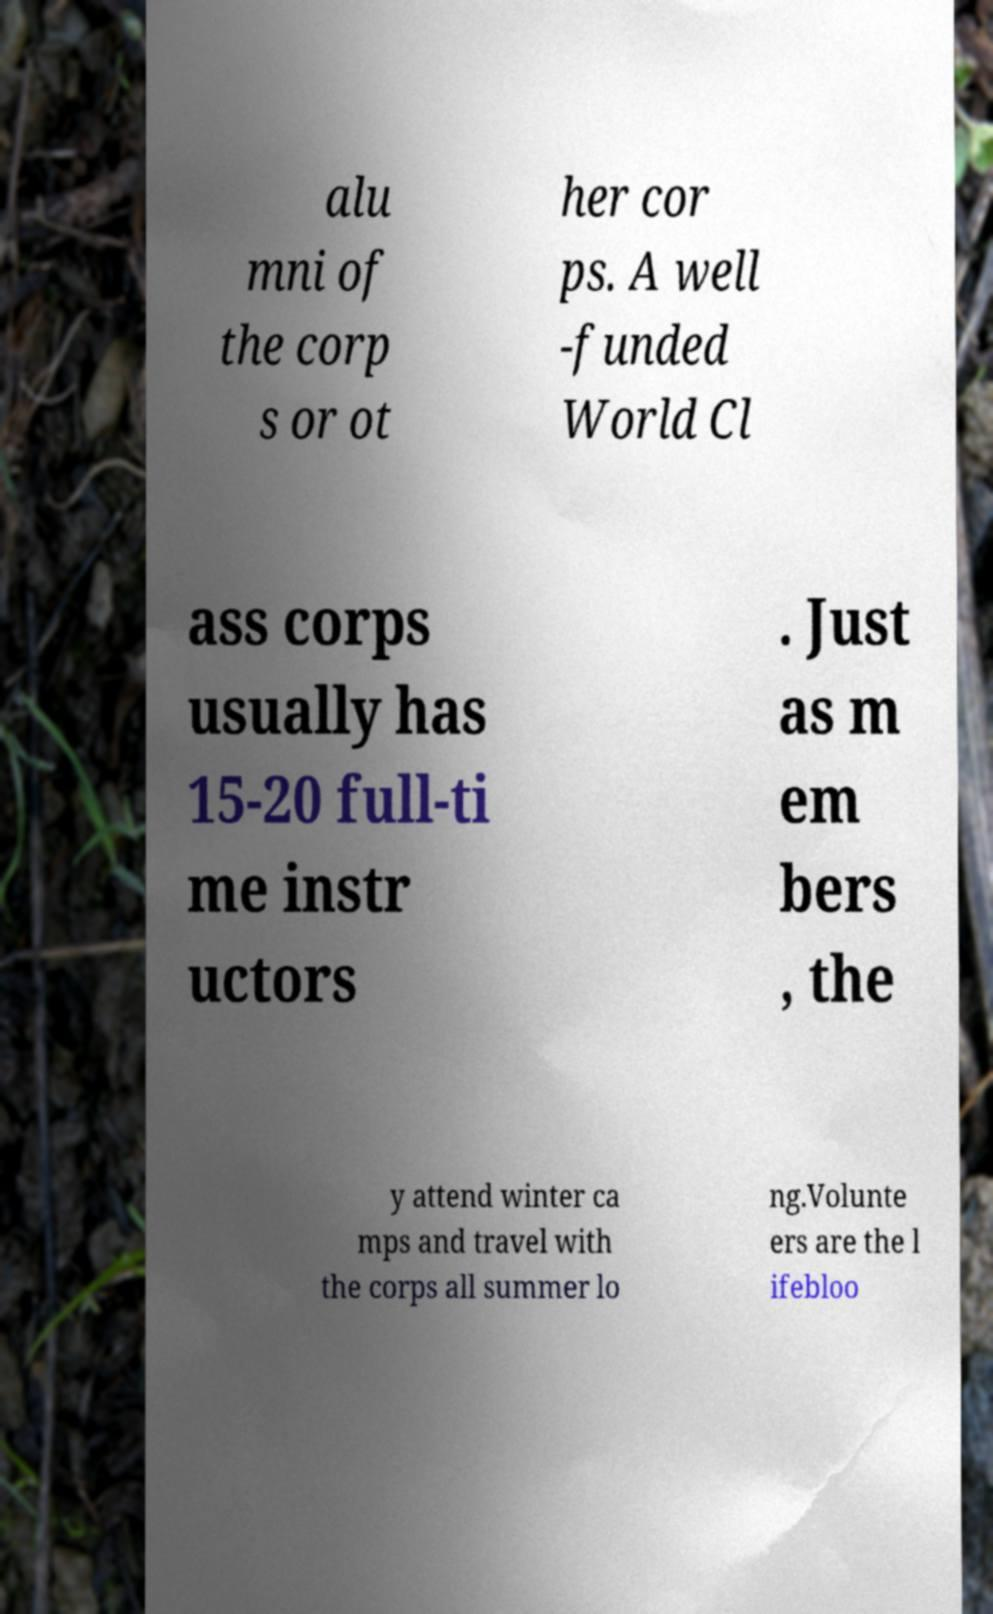For documentation purposes, I need the text within this image transcribed. Could you provide that? alu mni of the corp s or ot her cor ps. A well -funded World Cl ass corps usually has 15-20 full-ti me instr uctors . Just as m em bers , the y attend winter ca mps and travel with the corps all summer lo ng.Volunte ers are the l ifebloo 